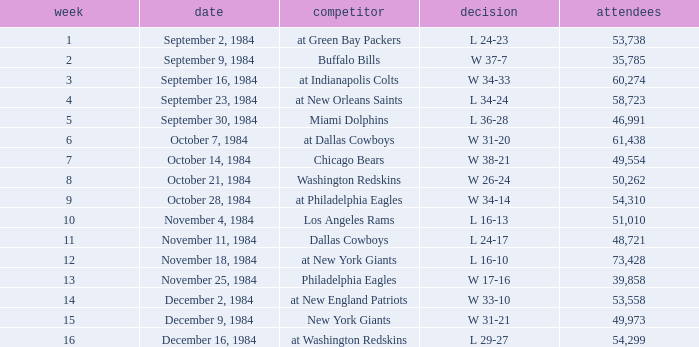Who was the opponent on October 14, 1984? Chicago Bears. 